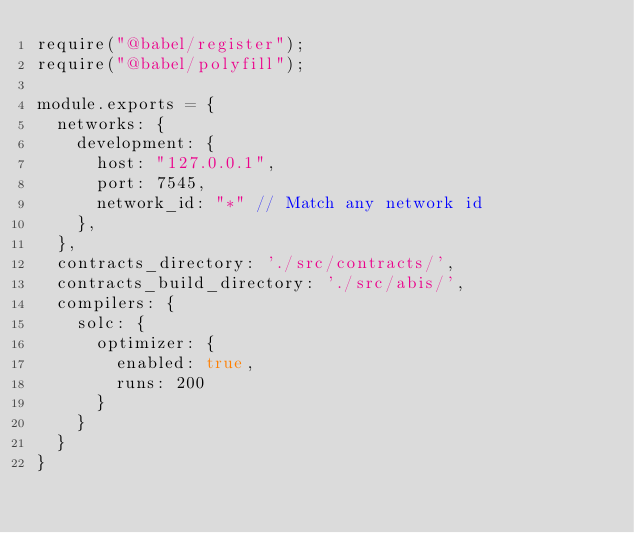Convert code to text. <code><loc_0><loc_0><loc_500><loc_500><_JavaScript_>require("@babel/register");
require("@babel/polyfill");

module.exports = {
  networks: {
    development: {
      host: "127.0.0.1",
      port: 7545,
      network_id: "*" // Match any network id
    },
  },
  contracts_directory: './src/contracts/',
  contracts_build_directory: './src/abis/',
  compilers: {
    solc: {
      optimizer: {
        enabled: true,
        runs: 200
      }
    }
  }
}
</code> 